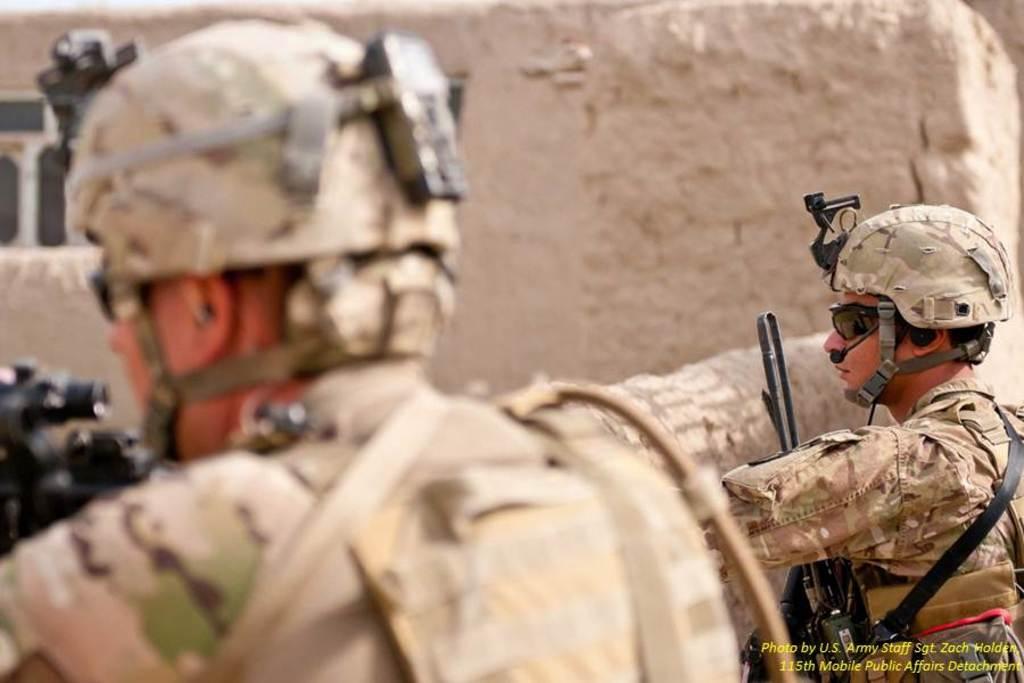Please provide a concise description of this image. In this picture we can see two people wore helmets, goggles and holding guns with their hands and in the background we can see a window, walls. 